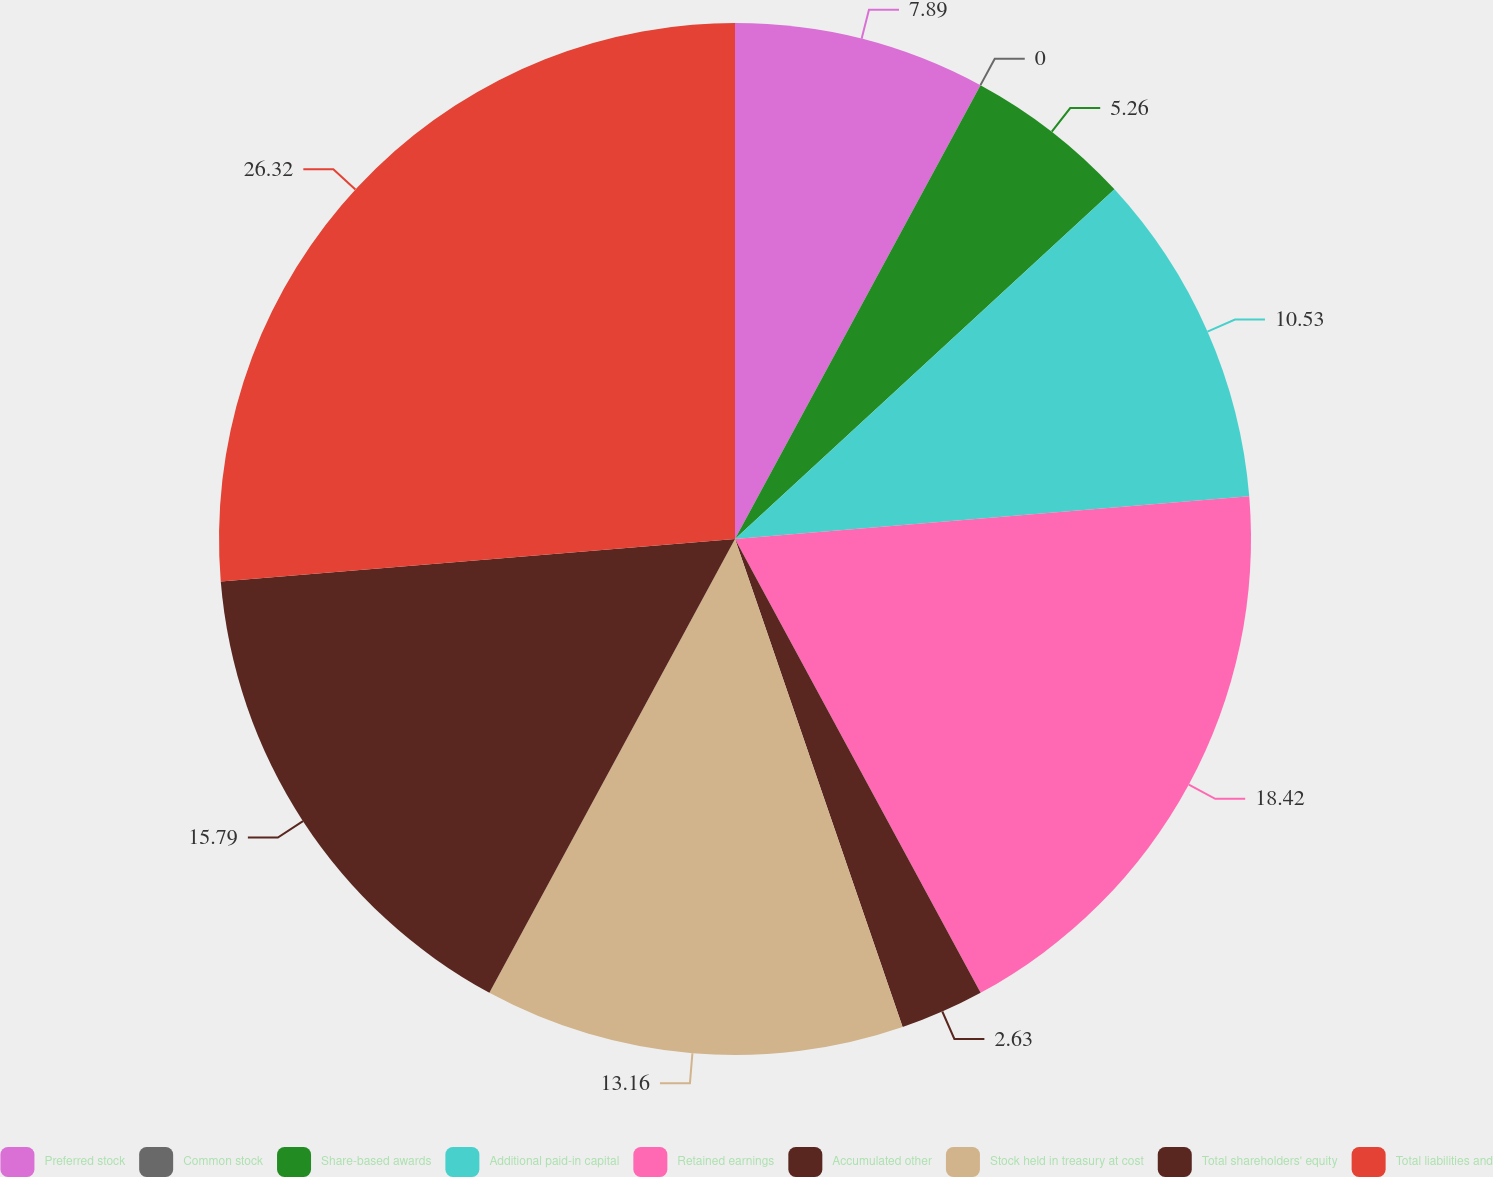Convert chart. <chart><loc_0><loc_0><loc_500><loc_500><pie_chart><fcel>Preferred stock<fcel>Common stock<fcel>Share-based awards<fcel>Additional paid-in capital<fcel>Retained earnings<fcel>Accumulated other<fcel>Stock held in treasury at cost<fcel>Total shareholders' equity<fcel>Total liabilities and<nl><fcel>7.89%<fcel>0.0%<fcel>5.26%<fcel>10.53%<fcel>18.42%<fcel>2.63%<fcel>13.16%<fcel>15.79%<fcel>26.31%<nl></chart> 